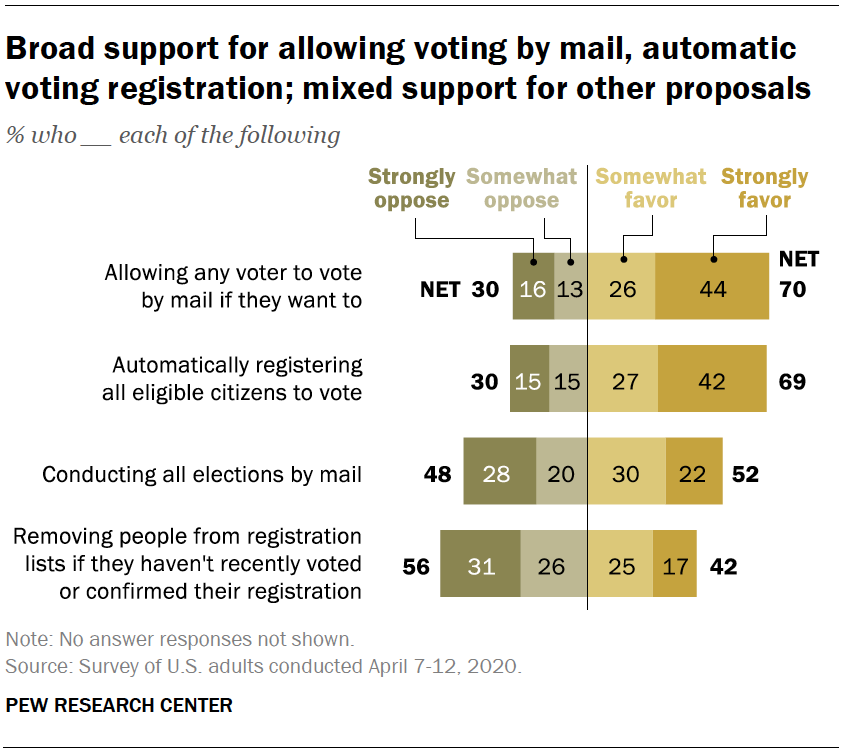Highlight a few significant elements in this photo. The graph is represented using 4 colors. There are three values in the category of 'Somewhat favor' with a rating below 30. 